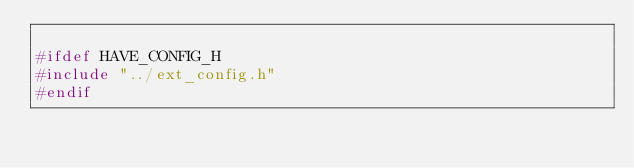<code> <loc_0><loc_0><loc_500><loc_500><_C_>
#ifdef HAVE_CONFIG_H
#include "../ext_config.h"
#endif
</code> 